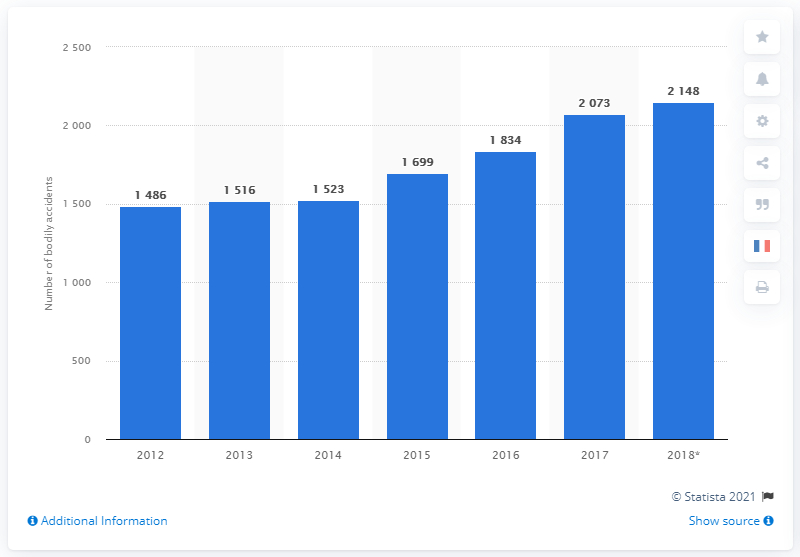Mention a couple of crucial points in this snapshot. In 2017, the number of accidents was greater than in 2012. In 2018, there were 2,148 accidents on the highway. 